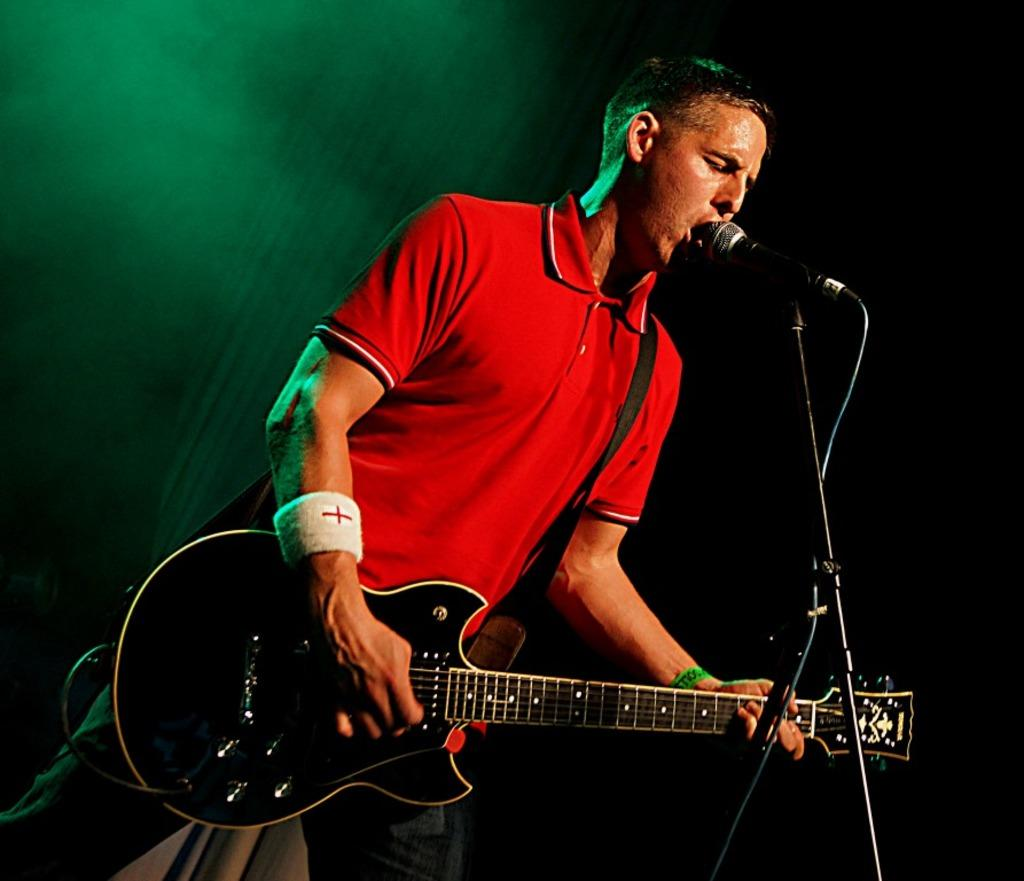Who is the main subject in the image? There is a man in the image. What is the man doing in the image? The man is standing, playing the guitar, singing a song, and using a microphone. What type of powder is the dog using to extinguish the fire in the image? There is no dog or fire present in the image, and therefore no such activity can be observed. 